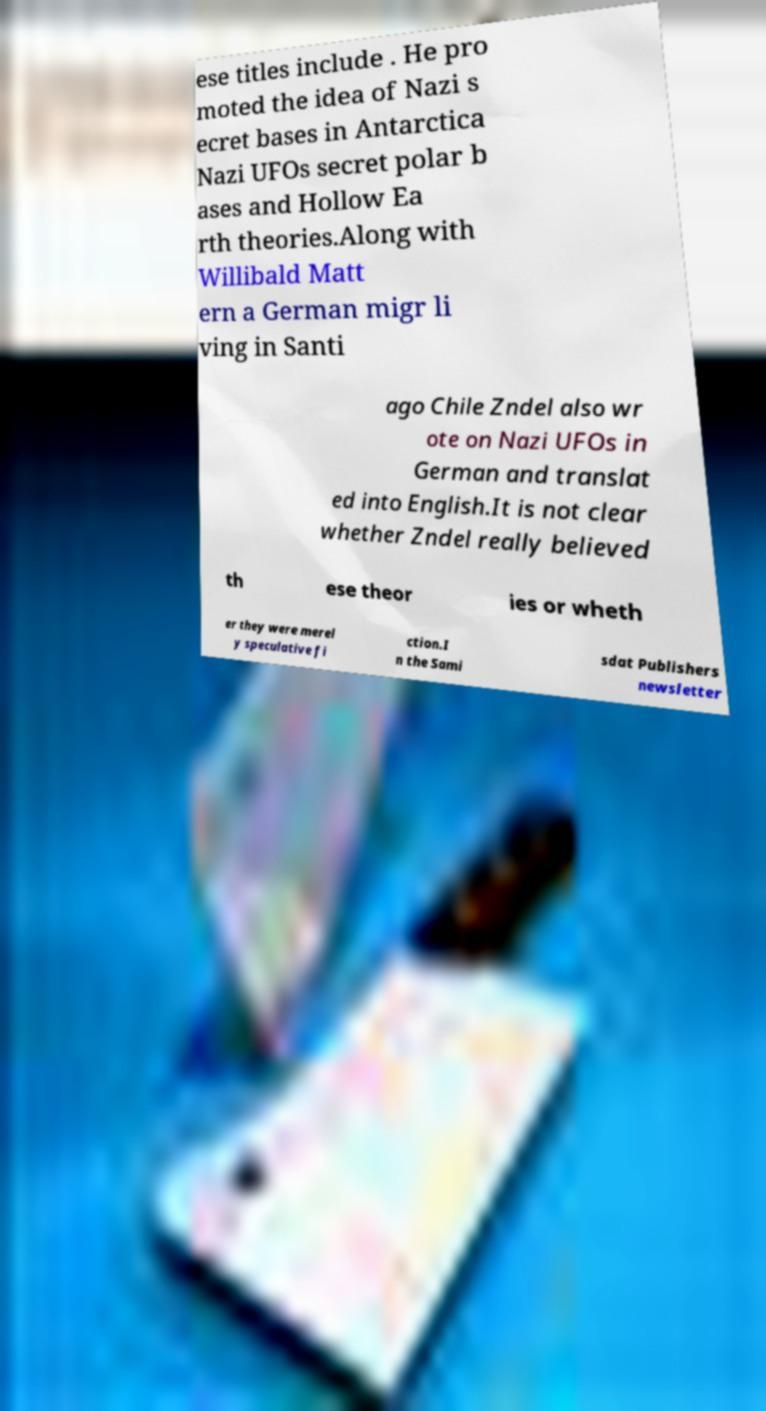What messages or text are displayed in this image? I need them in a readable, typed format. ese titles include . He pro moted the idea of Nazi s ecret bases in Antarctica Nazi UFOs secret polar b ases and Hollow Ea rth theories.Along with Willibald Matt ern a German migr li ving in Santi ago Chile Zndel also wr ote on Nazi UFOs in German and translat ed into English.It is not clear whether Zndel really believed th ese theor ies or wheth er they were merel y speculative fi ction.I n the Sami sdat Publishers newsletter 